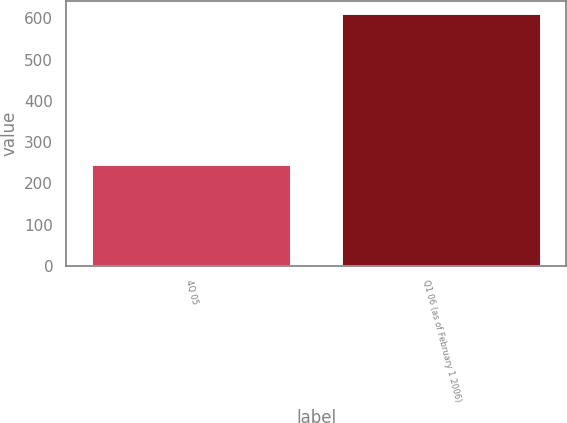<chart> <loc_0><loc_0><loc_500><loc_500><bar_chart><fcel>4Q 05<fcel>Q1 06 (as of February 1 2006)<nl><fcel>247<fcel>612<nl></chart> 